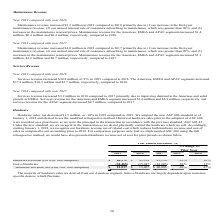According to Manhattan Associates's financial document, What is the revenue from hardware, net (Post ASC 606 Adoption) in 2019 According to the financial document, $12,517. The relevant text states: "Hardware Revenue, net (Post ASC 606 Adoption) $ 12,517 $ 13,967 $ 10,985 -10 % 27 %..." Also, What is the percentage change in cost of hardware between 2019 and 2018? According to the financial document, -10%. The relevant text states: "Hardware sales, net decreased $1.5 million, or -10% in 2019 compared to 2018. We adopted the new ASC 606 standard as of January 1, 2018 and elected to u..." Also, When is ASC 606 being adopted by the company? According to the financial document, January 1, 2018. The relevant text states: "o 2018. We adopted the new ASC 606 standard as of January 1, 2018 and elected to use the modified retrospective method. Historical hardware sales prior to the adopti o 2018. We adopted the new ASC 606..." Also, can you calculate: What is the change in hardware revenue, net (Post ASC 606 Adoption) between 2019 and 2017? Based on the calculation: $12,517-$10,985, the result is 1532. This is based on the information: ", net (Post ASC 606 Adoption) $ 12,517 $ 13,967 $ 10,985 -10 % 27 % Hardware Revenue, net (Post ASC 606 Adoption) $ 12,517 $ 13,967 $ 10,985 -10 % 27 %..." The key data points involved are: 10,985, 12,517. Also, can you calculate: What is the change in hardware revenue (Pre ASC 606 Adoption) in 2019 and 2018? Based on the calculation: $44,972-$49,914, the result is -4942. This is based on the information: "ardware Revenue (Pre ASC 606 Adoption) $ 44,972 $ 49,914 43,190 -10 % 16 % Hardware Revenue (Pre ASC 606 Adoption) $ 44,972 $ 49,914 43,190 -10 % 16 %..." The key data points involved are: 44,972, 49,914. Also, can you calculate: What is the sum of cost of hardware for 2019 and 2018? Based on the calculation: $32,455+$35,947, the result is 68402. This is based on the information: "Cost of hardware (32,455 ) (35,947 ) (32,205 ) -10 % 12 % Cost of hardware (32,455 ) (35,947 ) (32,205 ) -10 % 12 %..." The key data points involved are: 32,455, 35,947. 